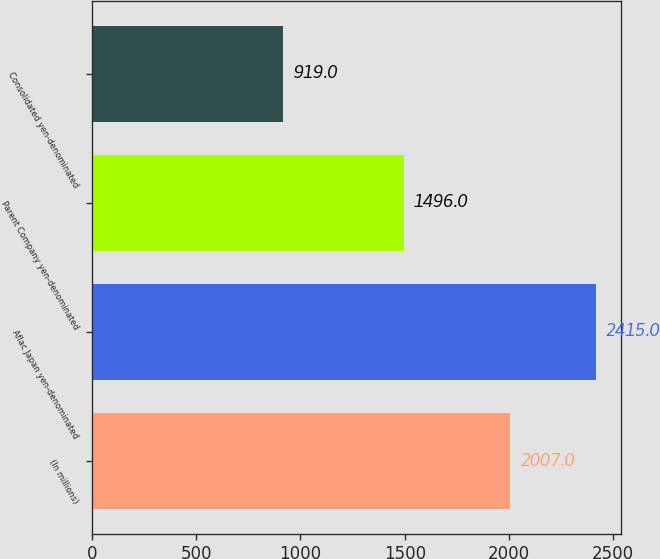Convert chart. <chart><loc_0><loc_0><loc_500><loc_500><bar_chart><fcel>(In millions)<fcel>Aflac Japan yen-denominated<fcel>Parent Company yen-denominated<fcel>Consolidated yen-denominated<nl><fcel>2007<fcel>2415<fcel>1496<fcel>919<nl></chart> 